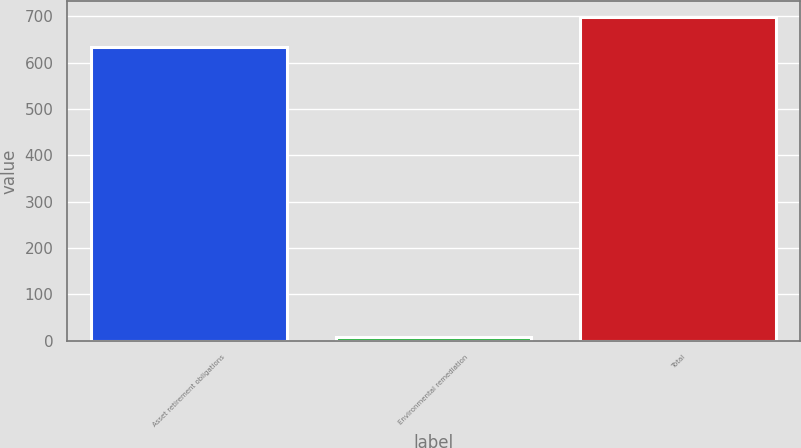Convert chart to OTSL. <chart><loc_0><loc_0><loc_500><loc_500><bar_chart><fcel>Asset retirement obligations<fcel>Environmental remediation<fcel>Total<nl><fcel>634.3<fcel>8<fcel>697.73<nl></chart> 